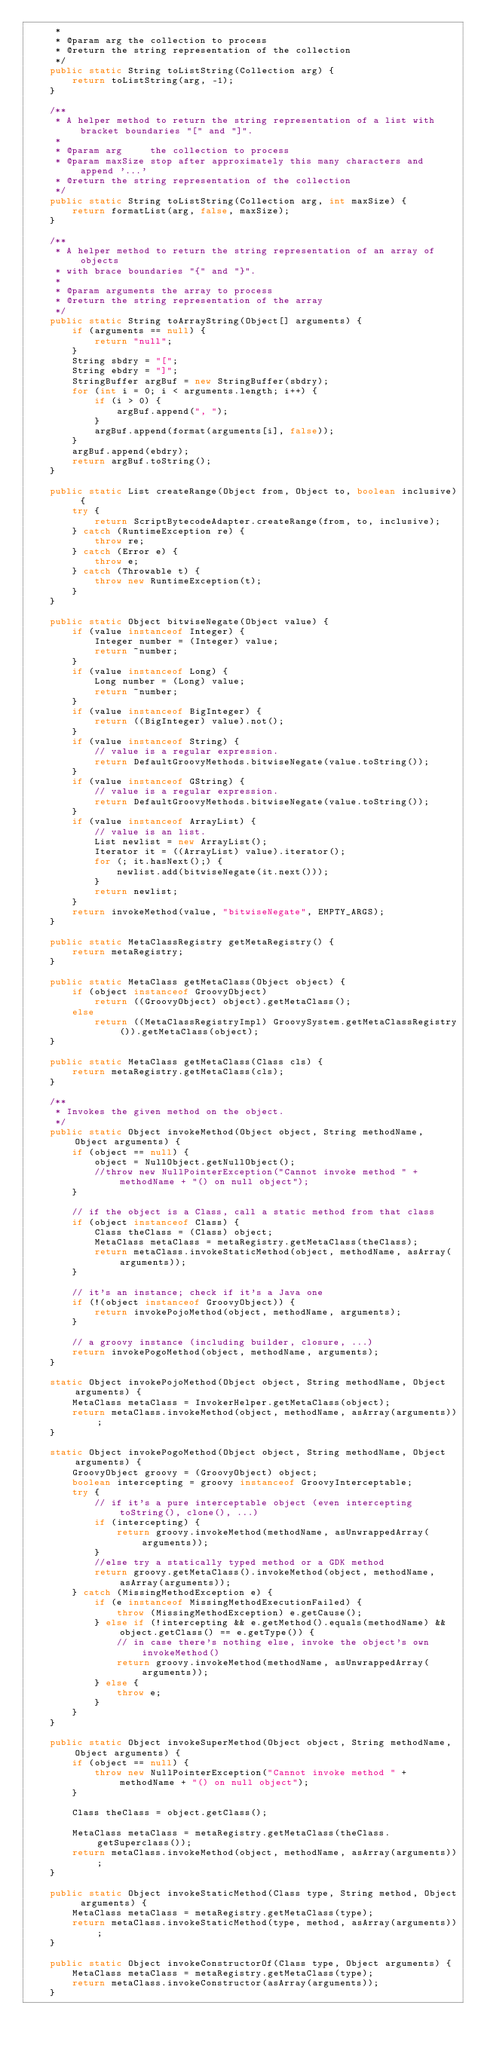Convert code to text. <code><loc_0><loc_0><loc_500><loc_500><_Java_>     *
     * @param arg the collection to process
     * @return the string representation of the collection
     */
    public static String toListString(Collection arg) {
        return toListString(arg, -1);
    }

    /**
     * A helper method to return the string representation of a list with bracket boundaries "[" and "]".
     *
     * @param arg     the collection to process
     * @param maxSize stop after approximately this many characters and append '...'
     * @return the string representation of the collection
     */
    public static String toListString(Collection arg, int maxSize) {
        return formatList(arg, false, maxSize);
    }

    /**
     * A helper method to return the string representation of an array of objects
     * with brace boundaries "{" and "}".
     *
     * @param arguments the array to process
     * @return the string representation of the array
     */
    public static String toArrayString(Object[] arguments) {
        if (arguments == null) {
            return "null";
        }
        String sbdry = "[";
        String ebdry = "]";
        StringBuffer argBuf = new StringBuffer(sbdry);
        for (int i = 0; i < arguments.length; i++) {
            if (i > 0) {
                argBuf.append(", ");
            }
            argBuf.append(format(arguments[i], false));
        }
        argBuf.append(ebdry);
        return argBuf.toString();
    }

    public static List createRange(Object from, Object to, boolean inclusive) {
        try {
            return ScriptBytecodeAdapter.createRange(from, to, inclusive);
        } catch (RuntimeException re) {
            throw re;
        } catch (Error e) {
            throw e;
        } catch (Throwable t) {
            throw new RuntimeException(t);
        }
    }

    public static Object bitwiseNegate(Object value) {
        if (value instanceof Integer) {
            Integer number = (Integer) value;
            return ~number;
        }
        if (value instanceof Long) {
            Long number = (Long) value;
            return ~number;
        }
        if (value instanceof BigInteger) {
            return ((BigInteger) value).not();
        }
        if (value instanceof String) {
            // value is a regular expression.
            return DefaultGroovyMethods.bitwiseNegate(value.toString());
        }
        if (value instanceof GString) {
            // value is a regular expression.
            return DefaultGroovyMethods.bitwiseNegate(value.toString());
        }
        if (value instanceof ArrayList) {
            // value is an list.
            List newlist = new ArrayList();
            Iterator it = ((ArrayList) value).iterator();
            for (; it.hasNext();) {
                newlist.add(bitwiseNegate(it.next()));
            }
            return newlist;
        }
        return invokeMethod(value, "bitwiseNegate", EMPTY_ARGS);
    }

    public static MetaClassRegistry getMetaRegistry() {
        return metaRegistry;
    }

    public static MetaClass getMetaClass(Object object) {
        if (object instanceof GroovyObject)
            return ((GroovyObject) object).getMetaClass();
        else
            return ((MetaClassRegistryImpl) GroovySystem.getMetaClassRegistry()).getMetaClass(object);
    }

    public static MetaClass getMetaClass(Class cls) {
        return metaRegistry.getMetaClass(cls);
    }

    /**
     * Invokes the given method on the object.
     */
    public static Object invokeMethod(Object object, String methodName, Object arguments) {
        if (object == null) {
            object = NullObject.getNullObject();
            //throw new NullPointerException("Cannot invoke method " + methodName + "() on null object");
        }

        // if the object is a Class, call a static method from that class
        if (object instanceof Class) {
            Class theClass = (Class) object;
            MetaClass metaClass = metaRegistry.getMetaClass(theClass);
            return metaClass.invokeStaticMethod(object, methodName, asArray(arguments));
        }

        // it's an instance; check if it's a Java one
        if (!(object instanceof GroovyObject)) {
            return invokePojoMethod(object, methodName, arguments);
        }

        // a groovy instance (including builder, closure, ...)
        return invokePogoMethod(object, methodName, arguments);
    }

    static Object invokePojoMethod(Object object, String methodName, Object arguments) {
        MetaClass metaClass = InvokerHelper.getMetaClass(object);
        return metaClass.invokeMethod(object, methodName, asArray(arguments));
    }

    static Object invokePogoMethod(Object object, String methodName, Object arguments) {
        GroovyObject groovy = (GroovyObject) object;
        boolean intercepting = groovy instanceof GroovyInterceptable;
        try {
            // if it's a pure interceptable object (even intercepting toString(), clone(), ...)
            if (intercepting) {
                return groovy.invokeMethod(methodName, asUnwrappedArray(arguments));
            }
            //else try a statically typed method or a GDK method
            return groovy.getMetaClass().invokeMethod(object, methodName, asArray(arguments));
        } catch (MissingMethodException e) {
            if (e instanceof MissingMethodExecutionFailed) {
                throw (MissingMethodException) e.getCause();
            } else if (!intercepting && e.getMethod().equals(methodName) && object.getClass() == e.getType()) {
                // in case there's nothing else, invoke the object's own invokeMethod()
                return groovy.invokeMethod(methodName, asUnwrappedArray(arguments));
            } else {
                throw e;
            }
        }
    }

    public static Object invokeSuperMethod(Object object, String methodName, Object arguments) {
        if (object == null) {
            throw new NullPointerException("Cannot invoke method " + methodName + "() on null object");
        }

        Class theClass = object.getClass();

        MetaClass metaClass = metaRegistry.getMetaClass(theClass.getSuperclass());
        return metaClass.invokeMethod(object, methodName, asArray(arguments));
    }

    public static Object invokeStaticMethod(Class type, String method, Object arguments) {
        MetaClass metaClass = metaRegistry.getMetaClass(type);
        return metaClass.invokeStaticMethod(type, method, asArray(arguments));
    }

    public static Object invokeConstructorOf(Class type, Object arguments) {
        MetaClass metaClass = metaRegistry.getMetaClass(type);
        return metaClass.invokeConstructor(asArray(arguments));
    }
</code> 